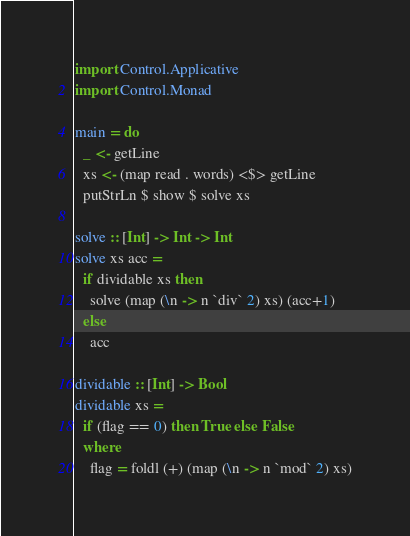<code> <loc_0><loc_0><loc_500><loc_500><_Haskell_>import Control.Applicative
import Control.Monad

main = do
  _ <- getLine
  xs <- (map read . words) <$> getLine
  putStrLn $ show $ solve xs
  
solve :: [Int] -> Int -> Int
solve xs acc =
  if dividable xs then
    solve (map (\n -> n `div` 2) xs) (acc+1)
  else
    acc
    
dividable :: [Int] -> Bool
dividable xs =
  if (flag == 0) then True else False
  where
    flag = foldl (+) (map (\n -> n `mod` 2) xs)</code> 